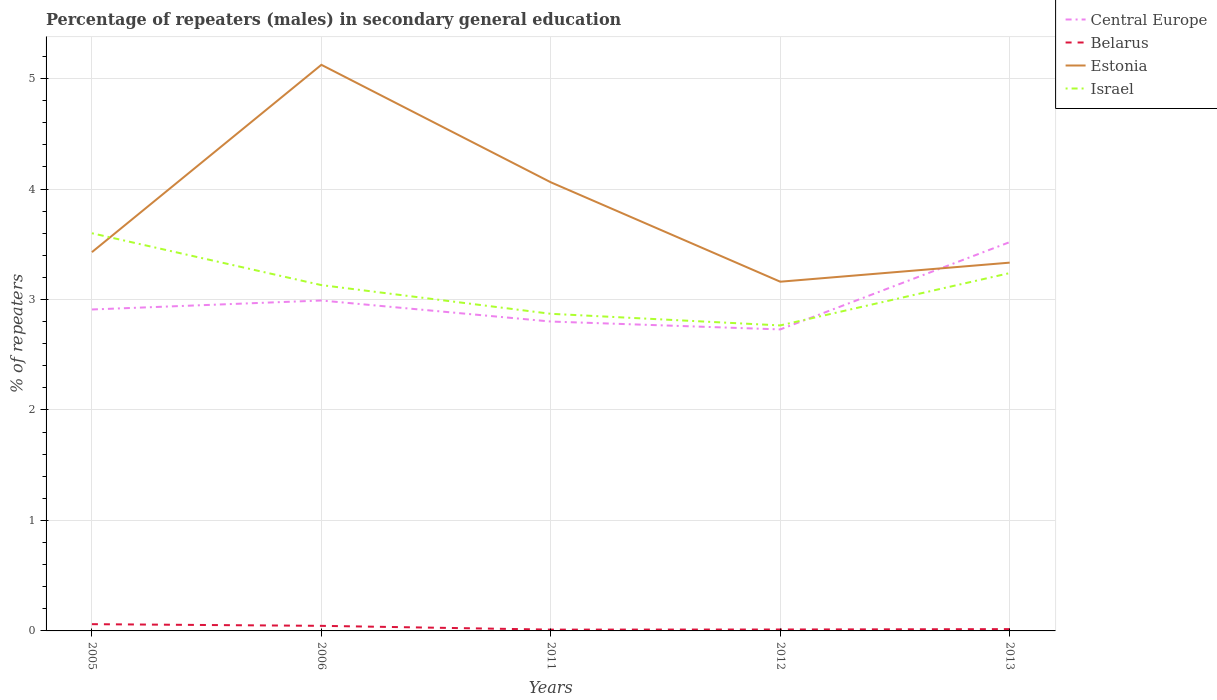How many different coloured lines are there?
Your answer should be compact. 4. Does the line corresponding to Israel intersect with the line corresponding to Central Europe?
Offer a terse response. Yes. Across all years, what is the maximum percentage of male repeaters in Belarus?
Keep it short and to the point. 0.01. In which year was the percentage of male repeaters in Belarus maximum?
Make the answer very short. 2011. What is the total percentage of male repeaters in Estonia in the graph?
Keep it short and to the point. 0.9. What is the difference between the highest and the second highest percentage of male repeaters in Estonia?
Your answer should be very brief. 1.96. How many years are there in the graph?
Your response must be concise. 5. What is the difference between two consecutive major ticks on the Y-axis?
Offer a very short reply. 1. Are the values on the major ticks of Y-axis written in scientific E-notation?
Your response must be concise. No. Does the graph contain grids?
Offer a terse response. Yes. How are the legend labels stacked?
Your response must be concise. Vertical. What is the title of the graph?
Provide a succinct answer. Percentage of repeaters (males) in secondary general education. What is the label or title of the X-axis?
Give a very brief answer. Years. What is the label or title of the Y-axis?
Offer a terse response. % of repeaters. What is the % of repeaters in Central Europe in 2005?
Give a very brief answer. 2.91. What is the % of repeaters in Belarus in 2005?
Provide a succinct answer. 0.06. What is the % of repeaters in Estonia in 2005?
Offer a terse response. 3.43. What is the % of repeaters of Israel in 2005?
Give a very brief answer. 3.6. What is the % of repeaters in Central Europe in 2006?
Make the answer very short. 2.99. What is the % of repeaters in Belarus in 2006?
Give a very brief answer. 0.05. What is the % of repeaters of Estonia in 2006?
Offer a terse response. 5.12. What is the % of repeaters of Israel in 2006?
Your response must be concise. 3.13. What is the % of repeaters in Central Europe in 2011?
Offer a very short reply. 2.8. What is the % of repeaters in Belarus in 2011?
Give a very brief answer. 0.01. What is the % of repeaters in Estonia in 2011?
Your answer should be compact. 4.06. What is the % of repeaters of Israel in 2011?
Give a very brief answer. 2.87. What is the % of repeaters in Central Europe in 2012?
Your answer should be compact. 2.73. What is the % of repeaters in Belarus in 2012?
Your answer should be very brief. 0.01. What is the % of repeaters in Estonia in 2012?
Offer a very short reply. 3.16. What is the % of repeaters of Israel in 2012?
Keep it short and to the point. 2.77. What is the % of repeaters in Central Europe in 2013?
Make the answer very short. 3.52. What is the % of repeaters in Belarus in 2013?
Your response must be concise. 0.02. What is the % of repeaters in Estonia in 2013?
Offer a terse response. 3.33. What is the % of repeaters of Israel in 2013?
Make the answer very short. 3.24. Across all years, what is the maximum % of repeaters of Central Europe?
Your answer should be compact. 3.52. Across all years, what is the maximum % of repeaters of Belarus?
Provide a succinct answer. 0.06. Across all years, what is the maximum % of repeaters in Estonia?
Offer a very short reply. 5.12. Across all years, what is the maximum % of repeaters of Israel?
Give a very brief answer. 3.6. Across all years, what is the minimum % of repeaters of Central Europe?
Offer a terse response. 2.73. Across all years, what is the minimum % of repeaters in Belarus?
Offer a very short reply. 0.01. Across all years, what is the minimum % of repeaters of Estonia?
Keep it short and to the point. 3.16. Across all years, what is the minimum % of repeaters of Israel?
Offer a very short reply. 2.77. What is the total % of repeaters of Central Europe in the graph?
Provide a short and direct response. 14.95. What is the total % of repeaters in Belarus in the graph?
Ensure brevity in your answer.  0.15. What is the total % of repeaters of Estonia in the graph?
Make the answer very short. 19.11. What is the total % of repeaters in Israel in the graph?
Give a very brief answer. 15.6. What is the difference between the % of repeaters in Central Europe in 2005 and that in 2006?
Make the answer very short. -0.08. What is the difference between the % of repeaters in Belarus in 2005 and that in 2006?
Offer a terse response. 0.02. What is the difference between the % of repeaters of Estonia in 2005 and that in 2006?
Provide a short and direct response. -1.7. What is the difference between the % of repeaters of Israel in 2005 and that in 2006?
Offer a very short reply. 0.47. What is the difference between the % of repeaters of Central Europe in 2005 and that in 2011?
Provide a succinct answer. 0.11. What is the difference between the % of repeaters in Belarus in 2005 and that in 2011?
Your answer should be very brief. 0.05. What is the difference between the % of repeaters of Estonia in 2005 and that in 2011?
Give a very brief answer. -0.63. What is the difference between the % of repeaters of Israel in 2005 and that in 2011?
Offer a terse response. 0.73. What is the difference between the % of repeaters in Central Europe in 2005 and that in 2012?
Offer a terse response. 0.18. What is the difference between the % of repeaters in Belarus in 2005 and that in 2012?
Your answer should be very brief. 0.05. What is the difference between the % of repeaters of Estonia in 2005 and that in 2012?
Provide a short and direct response. 0.27. What is the difference between the % of repeaters of Israel in 2005 and that in 2012?
Offer a very short reply. 0.83. What is the difference between the % of repeaters in Central Europe in 2005 and that in 2013?
Make the answer very short. -0.61. What is the difference between the % of repeaters of Belarus in 2005 and that in 2013?
Give a very brief answer. 0.04. What is the difference between the % of repeaters in Estonia in 2005 and that in 2013?
Provide a short and direct response. 0.09. What is the difference between the % of repeaters of Israel in 2005 and that in 2013?
Ensure brevity in your answer.  0.36. What is the difference between the % of repeaters of Central Europe in 2006 and that in 2011?
Offer a terse response. 0.19. What is the difference between the % of repeaters of Belarus in 2006 and that in 2011?
Your answer should be very brief. 0.03. What is the difference between the % of repeaters of Estonia in 2006 and that in 2011?
Your response must be concise. 1.06. What is the difference between the % of repeaters in Israel in 2006 and that in 2011?
Ensure brevity in your answer.  0.26. What is the difference between the % of repeaters in Central Europe in 2006 and that in 2012?
Provide a succinct answer. 0.26. What is the difference between the % of repeaters of Belarus in 2006 and that in 2012?
Make the answer very short. 0.03. What is the difference between the % of repeaters of Estonia in 2006 and that in 2012?
Offer a terse response. 1.96. What is the difference between the % of repeaters of Israel in 2006 and that in 2012?
Your answer should be very brief. 0.36. What is the difference between the % of repeaters of Central Europe in 2006 and that in 2013?
Give a very brief answer. -0.53. What is the difference between the % of repeaters in Belarus in 2006 and that in 2013?
Ensure brevity in your answer.  0.03. What is the difference between the % of repeaters of Estonia in 2006 and that in 2013?
Your response must be concise. 1.79. What is the difference between the % of repeaters of Israel in 2006 and that in 2013?
Your answer should be compact. -0.11. What is the difference between the % of repeaters of Central Europe in 2011 and that in 2012?
Keep it short and to the point. 0.07. What is the difference between the % of repeaters of Belarus in 2011 and that in 2012?
Provide a succinct answer. -0. What is the difference between the % of repeaters in Estonia in 2011 and that in 2012?
Your answer should be very brief. 0.9. What is the difference between the % of repeaters in Israel in 2011 and that in 2012?
Your response must be concise. 0.11. What is the difference between the % of repeaters in Central Europe in 2011 and that in 2013?
Your response must be concise. -0.72. What is the difference between the % of repeaters in Belarus in 2011 and that in 2013?
Your response must be concise. -0. What is the difference between the % of repeaters in Estonia in 2011 and that in 2013?
Ensure brevity in your answer.  0.73. What is the difference between the % of repeaters of Israel in 2011 and that in 2013?
Make the answer very short. -0.37. What is the difference between the % of repeaters in Central Europe in 2012 and that in 2013?
Your answer should be very brief. -0.79. What is the difference between the % of repeaters of Belarus in 2012 and that in 2013?
Give a very brief answer. -0. What is the difference between the % of repeaters in Estonia in 2012 and that in 2013?
Keep it short and to the point. -0.17. What is the difference between the % of repeaters of Israel in 2012 and that in 2013?
Your answer should be very brief. -0.47. What is the difference between the % of repeaters in Central Europe in 2005 and the % of repeaters in Belarus in 2006?
Provide a short and direct response. 2.86. What is the difference between the % of repeaters of Central Europe in 2005 and the % of repeaters of Estonia in 2006?
Ensure brevity in your answer.  -2.21. What is the difference between the % of repeaters of Central Europe in 2005 and the % of repeaters of Israel in 2006?
Keep it short and to the point. -0.22. What is the difference between the % of repeaters in Belarus in 2005 and the % of repeaters in Estonia in 2006?
Give a very brief answer. -5.06. What is the difference between the % of repeaters of Belarus in 2005 and the % of repeaters of Israel in 2006?
Offer a very short reply. -3.07. What is the difference between the % of repeaters of Estonia in 2005 and the % of repeaters of Israel in 2006?
Keep it short and to the point. 0.3. What is the difference between the % of repeaters of Central Europe in 2005 and the % of repeaters of Belarus in 2011?
Keep it short and to the point. 2.9. What is the difference between the % of repeaters of Central Europe in 2005 and the % of repeaters of Estonia in 2011?
Offer a terse response. -1.15. What is the difference between the % of repeaters of Central Europe in 2005 and the % of repeaters of Israel in 2011?
Keep it short and to the point. 0.04. What is the difference between the % of repeaters of Belarus in 2005 and the % of repeaters of Estonia in 2011?
Offer a terse response. -4. What is the difference between the % of repeaters in Belarus in 2005 and the % of repeaters in Israel in 2011?
Your answer should be very brief. -2.81. What is the difference between the % of repeaters of Estonia in 2005 and the % of repeaters of Israel in 2011?
Ensure brevity in your answer.  0.56. What is the difference between the % of repeaters in Central Europe in 2005 and the % of repeaters in Belarus in 2012?
Offer a very short reply. 2.9. What is the difference between the % of repeaters in Central Europe in 2005 and the % of repeaters in Estonia in 2012?
Offer a very short reply. -0.25. What is the difference between the % of repeaters of Central Europe in 2005 and the % of repeaters of Israel in 2012?
Ensure brevity in your answer.  0.14. What is the difference between the % of repeaters of Belarus in 2005 and the % of repeaters of Estonia in 2012?
Provide a short and direct response. -3.1. What is the difference between the % of repeaters of Belarus in 2005 and the % of repeaters of Israel in 2012?
Provide a succinct answer. -2.7. What is the difference between the % of repeaters of Estonia in 2005 and the % of repeaters of Israel in 2012?
Your answer should be very brief. 0.66. What is the difference between the % of repeaters in Central Europe in 2005 and the % of repeaters in Belarus in 2013?
Give a very brief answer. 2.89. What is the difference between the % of repeaters in Central Europe in 2005 and the % of repeaters in Estonia in 2013?
Offer a very short reply. -0.42. What is the difference between the % of repeaters of Central Europe in 2005 and the % of repeaters of Israel in 2013?
Your answer should be compact. -0.33. What is the difference between the % of repeaters of Belarus in 2005 and the % of repeaters of Estonia in 2013?
Offer a very short reply. -3.27. What is the difference between the % of repeaters in Belarus in 2005 and the % of repeaters in Israel in 2013?
Your answer should be very brief. -3.18. What is the difference between the % of repeaters of Estonia in 2005 and the % of repeaters of Israel in 2013?
Provide a short and direct response. 0.19. What is the difference between the % of repeaters in Central Europe in 2006 and the % of repeaters in Belarus in 2011?
Offer a very short reply. 2.98. What is the difference between the % of repeaters in Central Europe in 2006 and the % of repeaters in Estonia in 2011?
Provide a short and direct response. -1.07. What is the difference between the % of repeaters in Central Europe in 2006 and the % of repeaters in Israel in 2011?
Your answer should be very brief. 0.12. What is the difference between the % of repeaters in Belarus in 2006 and the % of repeaters in Estonia in 2011?
Offer a very short reply. -4.01. What is the difference between the % of repeaters of Belarus in 2006 and the % of repeaters of Israel in 2011?
Give a very brief answer. -2.82. What is the difference between the % of repeaters of Estonia in 2006 and the % of repeaters of Israel in 2011?
Offer a very short reply. 2.25. What is the difference between the % of repeaters of Central Europe in 2006 and the % of repeaters of Belarus in 2012?
Make the answer very short. 2.98. What is the difference between the % of repeaters in Central Europe in 2006 and the % of repeaters in Estonia in 2012?
Make the answer very short. -0.17. What is the difference between the % of repeaters in Central Europe in 2006 and the % of repeaters in Israel in 2012?
Offer a very short reply. 0.23. What is the difference between the % of repeaters in Belarus in 2006 and the % of repeaters in Estonia in 2012?
Ensure brevity in your answer.  -3.12. What is the difference between the % of repeaters of Belarus in 2006 and the % of repeaters of Israel in 2012?
Provide a succinct answer. -2.72. What is the difference between the % of repeaters of Estonia in 2006 and the % of repeaters of Israel in 2012?
Provide a succinct answer. 2.36. What is the difference between the % of repeaters of Central Europe in 2006 and the % of repeaters of Belarus in 2013?
Ensure brevity in your answer.  2.97. What is the difference between the % of repeaters in Central Europe in 2006 and the % of repeaters in Estonia in 2013?
Offer a terse response. -0.34. What is the difference between the % of repeaters in Central Europe in 2006 and the % of repeaters in Israel in 2013?
Keep it short and to the point. -0.25. What is the difference between the % of repeaters in Belarus in 2006 and the % of repeaters in Estonia in 2013?
Offer a terse response. -3.29. What is the difference between the % of repeaters in Belarus in 2006 and the % of repeaters in Israel in 2013?
Make the answer very short. -3.19. What is the difference between the % of repeaters in Estonia in 2006 and the % of repeaters in Israel in 2013?
Give a very brief answer. 1.89. What is the difference between the % of repeaters of Central Europe in 2011 and the % of repeaters of Belarus in 2012?
Offer a very short reply. 2.79. What is the difference between the % of repeaters in Central Europe in 2011 and the % of repeaters in Estonia in 2012?
Provide a succinct answer. -0.36. What is the difference between the % of repeaters of Central Europe in 2011 and the % of repeaters of Israel in 2012?
Give a very brief answer. 0.04. What is the difference between the % of repeaters in Belarus in 2011 and the % of repeaters in Estonia in 2012?
Your answer should be compact. -3.15. What is the difference between the % of repeaters in Belarus in 2011 and the % of repeaters in Israel in 2012?
Provide a short and direct response. -2.75. What is the difference between the % of repeaters of Estonia in 2011 and the % of repeaters of Israel in 2012?
Provide a short and direct response. 1.3. What is the difference between the % of repeaters of Central Europe in 2011 and the % of repeaters of Belarus in 2013?
Give a very brief answer. 2.78. What is the difference between the % of repeaters in Central Europe in 2011 and the % of repeaters in Estonia in 2013?
Offer a terse response. -0.53. What is the difference between the % of repeaters of Central Europe in 2011 and the % of repeaters of Israel in 2013?
Give a very brief answer. -0.44. What is the difference between the % of repeaters in Belarus in 2011 and the % of repeaters in Estonia in 2013?
Make the answer very short. -3.32. What is the difference between the % of repeaters in Belarus in 2011 and the % of repeaters in Israel in 2013?
Your response must be concise. -3.23. What is the difference between the % of repeaters in Estonia in 2011 and the % of repeaters in Israel in 2013?
Make the answer very short. 0.82. What is the difference between the % of repeaters in Central Europe in 2012 and the % of repeaters in Belarus in 2013?
Provide a succinct answer. 2.71. What is the difference between the % of repeaters of Central Europe in 2012 and the % of repeaters of Estonia in 2013?
Offer a very short reply. -0.6. What is the difference between the % of repeaters in Central Europe in 2012 and the % of repeaters in Israel in 2013?
Your answer should be very brief. -0.51. What is the difference between the % of repeaters of Belarus in 2012 and the % of repeaters of Estonia in 2013?
Offer a terse response. -3.32. What is the difference between the % of repeaters of Belarus in 2012 and the % of repeaters of Israel in 2013?
Ensure brevity in your answer.  -3.23. What is the difference between the % of repeaters of Estonia in 2012 and the % of repeaters of Israel in 2013?
Offer a terse response. -0.08. What is the average % of repeaters of Central Europe per year?
Give a very brief answer. 2.99. What is the average % of repeaters in Belarus per year?
Your answer should be very brief. 0.03. What is the average % of repeaters in Estonia per year?
Provide a succinct answer. 3.82. What is the average % of repeaters of Israel per year?
Provide a short and direct response. 3.12. In the year 2005, what is the difference between the % of repeaters of Central Europe and % of repeaters of Belarus?
Ensure brevity in your answer.  2.85. In the year 2005, what is the difference between the % of repeaters in Central Europe and % of repeaters in Estonia?
Give a very brief answer. -0.52. In the year 2005, what is the difference between the % of repeaters in Central Europe and % of repeaters in Israel?
Make the answer very short. -0.69. In the year 2005, what is the difference between the % of repeaters of Belarus and % of repeaters of Estonia?
Offer a terse response. -3.37. In the year 2005, what is the difference between the % of repeaters in Belarus and % of repeaters in Israel?
Make the answer very short. -3.54. In the year 2005, what is the difference between the % of repeaters in Estonia and % of repeaters in Israel?
Provide a short and direct response. -0.17. In the year 2006, what is the difference between the % of repeaters of Central Europe and % of repeaters of Belarus?
Offer a very short reply. 2.94. In the year 2006, what is the difference between the % of repeaters of Central Europe and % of repeaters of Estonia?
Provide a succinct answer. -2.13. In the year 2006, what is the difference between the % of repeaters of Central Europe and % of repeaters of Israel?
Keep it short and to the point. -0.14. In the year 2006, what is the difference between the % of repeaters of Belarus and % of repeaters of Estonia?
Ensure brevity in your answer.  -5.08. In the year 2006, what is the difference between the % of repeaters in Belarus and % of repeaters in Israel?
Give a very brief answer. -3.08. In the year 2006, what is the difference between the % of repeaters of Estonia and % of repeaters of Israel?
Offer a terse response. 1.99. In the year 2011, what is the difference between the % of repeaters of Central Europe and % of repeaters of Belarus?
Offer a terse response. 2.79. In the year 2011, what is the difference between the % of repeaters of Central Europe and % of repeaters of Estonia?
Provide a short and direct response. -1.26. In the year 2011, what is the difference between the % of repeaters in Central Europe and % of repeaters in Israel?
Provide a succinct answer. -0.07. In the year 2011, what is the difference between the % of repeaters in Belarus and % of repeaters in Estonia?
Your answer should be compact. -4.05. In the year 2011, what is the difference between the % of repeaters in Belarus and % of repeaters in Israel?
Make the answer very short. -2.86. In the year 2011, what is the difference between the % of repeaters in Estonia and % of repeaters in Israel?
Keep it short and to the point. 1.19. In the year 2012, what is the difference between the % of repeaters in Central Europe and % of repeaters in Belarus?
Ensure brevity in your answer.  2.72. In the year 2012, what is the difference between the % of repeaters of Central Europe and % of repeaters of Estonia?
Your answer should be very brief. -0.43. In the year 2012, what is the difference between the % of repeaters of Central Europe and % of repeaters of Israel?
Make the answer very short. -0.04. In the year 2012, what is the difference between the % of repeaters of Belarus and % of repeaters of Estonia?
Provide a succinct answer. -3.15. In the year 2012, what is the difference between the % of repeaters in Belarus and % of repeaters in Israel?
Provide a succinct answer. -2.75. In the year 2012, what is the difference between the % of repeaters of Estonia and % of repeaters of Israel?
Make the answer very short. 0.4. In the year 2013, what is the difference between the % of repeaters in Central Europe and % of repeaters in Belarus?
Keep it short and to the point. 3.5. In the year 2013, what is the difference between the % of repeaters of Central Europe and % of repeaters of Estonia?
Your answer should be compact. 0.19. In the year 2013, what is the difference between the % of repeaters in Central Europe and % of repeaters in Israel?
Offer a terse response. 0.28. In the year 2013, what is the difference between the % of repeaters in Belarus and % of repeaters in Estonia?
Offer a terse response. -3.32. In the year 2013, what is the difference between the % of repeaters in Belarus and % of repeaters in Israel?
Offer a terse response. -3.22. In the year 2013, what is the difference between the % of repeaters in Estonia and % of repeaters in Israel?
Make the answer very short. 0.09. What is the ratio of the % of repeaters in Central Europe in 2005 to that in 2006?
Keep it short and to the point. 0.97. What is the ratio of the % of repeaters of Belarus in 2005 to that in 2006?
Make the answer very short. 1.33. What is the ratio of the % of repeaters in Estonia in 2005 to that in 2006?
Keep it short and to the point. 0.67. What is the ratio of the % of repeaters of Israel in 2005 to that in 2006?
Make the answer very short. 1.15. What is the ratio of the % of repeaters in Central Europe in 2005 to that in 2011?
Your response must be concise. 1.04. What is the ratio of the % of repeaters in Belarus in 2005 to that in 2011?
Make the answer very short. 5.2. What is the ratio of the % of repeaters of Estonia in 2005 to that in 2011?
Your answer should be very brief. 0.84. What is the ratio of the % of repeaters in Israel in 2005 to that in 2011?
Offer a very short reply. 1.25. What is the ratio of the % of repeaters of Central Europe in 2005 to that in 2012?
Your answer should be very brief. 1.07. What is the ratio of the % of repeaters of Belarus in 2005 to that in 2012?
Your response must be concise. 4.75. What is the ratio of the % of repeaters of Estonia in 2005 to that in 2012?
Offer a terse response. 1.08. What is the ratio of the % of repeaters of Israel in 2005 to that in 2012?
Your answer should be very brief. 1.3. What is the ratio of the % of repeaters in Central Europe in 2005 to that in 2013?
Offer a very short reply. 0.83. What is the ratio of the % of repeaters of Belarus in 2005 to that in 2013?
Your answer should be very brief. 3.74. What is the ratio of the % of repeaters of Estonia in 2005 to that in 2013?
Ensure brevity in your answer.  1.03. What is the ratio of the % of repeaters of Israel in 2005 to that in 2013?
Your answer should be very brief. 1.11. What is the ratio of the % of repeaters of Central Europe in 2006 to that in 2011?
Provide a succinct answer. 1.07. What is the ratio of the % of repeaters of Belarus in 2006 to that in 2011?
Keep it short and to the point. 3.91. What is the ratio of the % of repeaters in Estonia in 2006 to that in 2011?
Your response must be concise. 1.26. What is the ratio of the % of repeaters of Israel in 2006 to that in 2011?
Ensure brevity in your answer.  1.09. What is the ratio of the % of repeaters of Central Europe in 2006 to that in 2012?
Your answer should be compact. 1.1. What is the ratio of the % of repeaters of Belarus in 2006 to that in 2012?
Keep it short and to the point. 3.57. What is the ratio of the % of repeaters of Estonia in 2006 to that in 2012?
Your response must be concise. 1.62. What is the ratio of the % of repeaters in Israel in 2006 to that in 2012?
Your response must be concise. 1.13. What is the ratio of the % of repeaters of Central Europe in 2006 to that in 2013?
Provide a succinct answer. 0.85. What is the ratio of the % of repeaters of Belarus in 2006 to that in 2013?
Provide a short and direct response. 2.82. What is the ratio of the % of repeaters in Estonia in 2006 to that in 2013?
Your answer should be very brief. 1.54. What is the ratio of the % of repeaters in Israel in 2006 to that in 2013?
Your answer should be very brief. 0.97. What is the ratio of the % of repeaters of Central Europe in 2011 to that in 2012?
Ensure brevity in your answer.  1.03. What is the ratio of the % of repeaters in Belarus in 2011 to that in 2012?
Keep it short and to the point. 0.91. What is the ratio of the % of repeaters in Estonia in 2011 to that in 2012?
Provide a short and direct response. 1.28. What is the ratio of the % of repeaters in Israel in 2011 to that in 2012?
Give a very brief answer. 1.04. What is the ratio of the % of repeaters in Central Europe in 2011 to that in 2013?
Your answer should be very brief. 0.8. What is the ratio of the % of repeaters of Belarus in 2011 to that in 2013?
Your answer should be very brief. 0.72. What is the ratio of the % of repeaters of Estonia in 2011 to that in 2013?
Your response must be concise. 1.22. What is the ratio of the % of repeaters of Israel in 2011 to that in 2013?
Offer a very short reply. 0.89. What is the ratio of the % of repeaters of Central Europe in 2012 to that in 2013?
Make the answer very short. 0.78. What is the ratio of the % of repeaters in Belarus in 2012 to that in 2013?
Provide a succinct answer. 0.79. What is the ratio of the % of repeaters in Estonia in 2012 to that in 2013?
Your answer should be compact. 0.95. What is the ratio of the % of repeaters in Israel in 2012 to that in 2013?
Provide a short and direct response. 0.85. What is the difference between the highest and the second highest % of repeaters in Central Europe?
Offer a terse response. 0.53. What is the difference between the highest and the second highest % of repeaters in Belarus?
Ensure brevity in your answer.  0.02. What is the difference between the highest and the second highest % of repeaters of Estonia?
Provide a succinct answer. 1.06. What is the difference between the highest and the second highest % of repeaters of Israel?
Ensure brevity in your answer.  0.36. What is the difference between the highest and the lowest % of repeaters of Central Europe?
Offer a very short reply. 0.79. What is the difference between the highest and the lowest % of repeaters of Belarus?
Your answer should be compact. 0.05. What is the difference between the highest and the lowest % of repeaters of Estonia?
Your answer should be compact. 1.96. What is the difference between the highest and the lowest % of repeaters of Israel?
Keep it short and to the point. 0.83. 